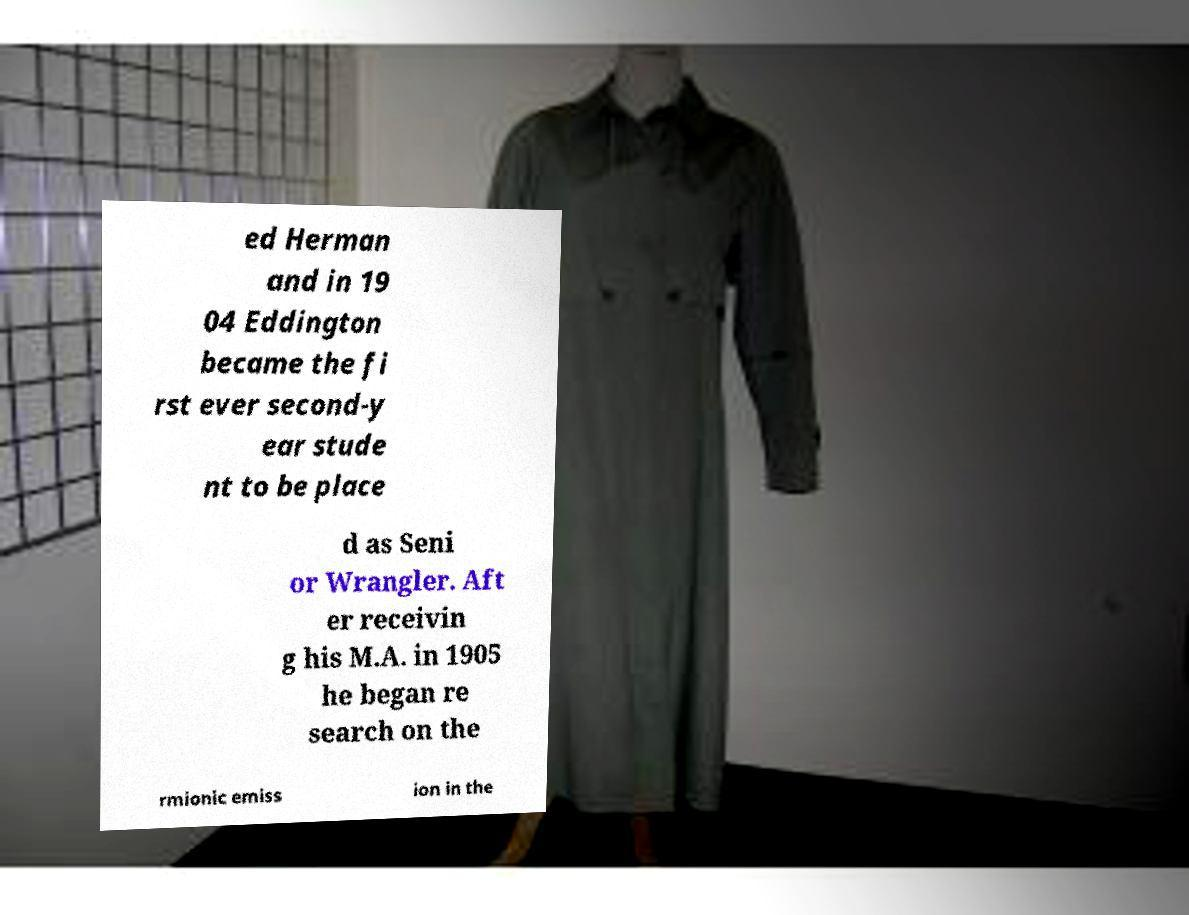Can you accurately transcribe the text from the provided image for me? ed Herman and in 19 04 Eddington became the fi rst ever second-y ear stude nt to be place d as Seni or Wrangler. Aft er receivin g his M.A. in 1905 he began re search on the rmionic emiss ion in the 